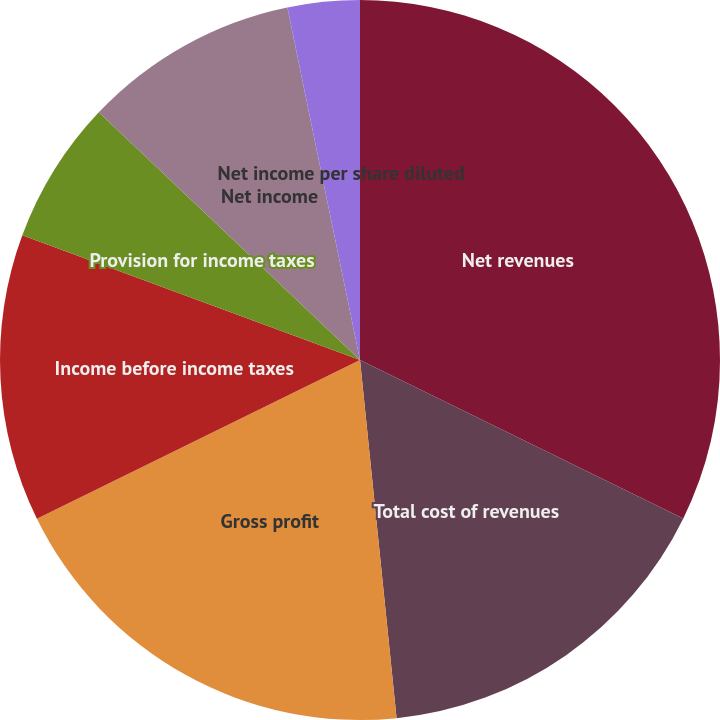<chart> <loc_0><loc_0><loc_500><loc_500><pie_chart><fcel>Net revenues<fcel>Total cost of revenues<fcel>Gross profit<fcel>Income before income taxes<fcel>Provision for income taxes<fcel>Net income<fcel>Net income per share basic<fcel>Net income per share diluted<nl><fcel>32.25%<fcel>16.13%<fcel>19.35%<fcel>12.9%<fcel>6.45%<fcel>9.68%<fcel>0.01%<fcel>3.23%<nl></chart> 